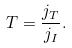<formula> <loc_0><loc_0><loc_500><loc_500>T = \frac { j _ { T } } { j _ { I } } .</formula> 